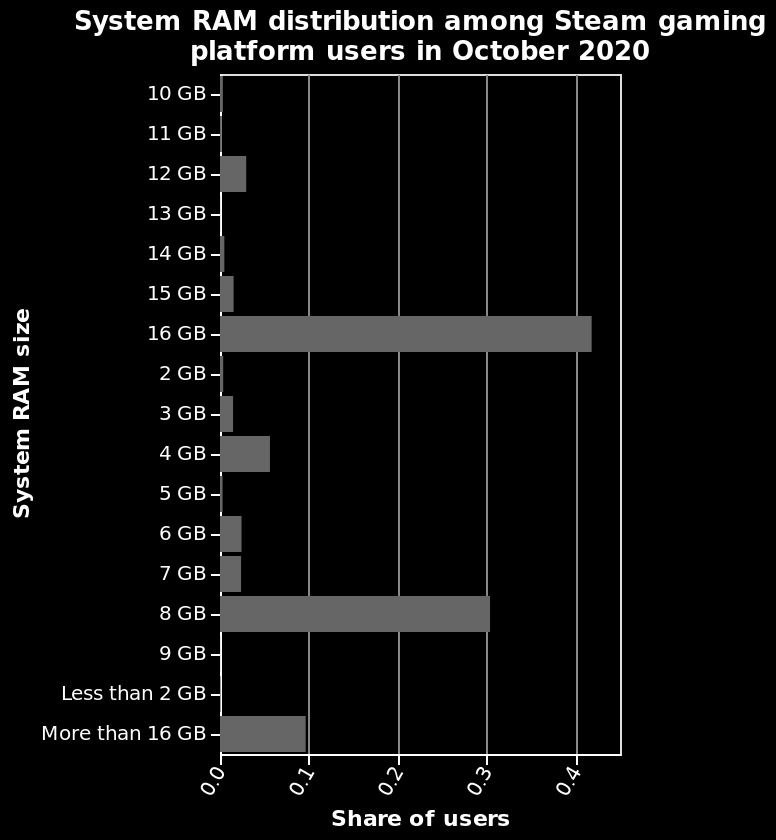<image>
Are there any machines with a RAM size greater than 16GB? Yes, there are a few machines with a RAM size greater than 16GB. What is the main RAM size? The main RAM size is 16GB. 